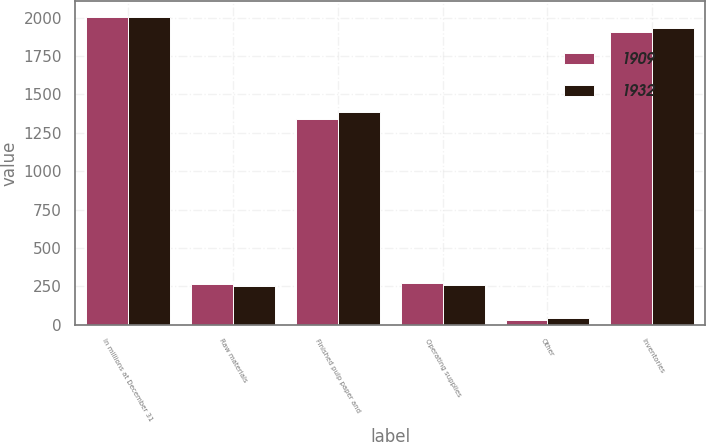Convert chart. <chart><loc_0><loc_0><loc_500><loc_500><stacked_bar_chart><ecel><fcel>In millions at December 31<fcel>Raw materials<fcel>Finished pulp paper and<fcel>Operating supplies<fcel>Other<fcel>Inventories<nl><fcel>1909<fcel>2006<fcel>265<fcel>1341<fcel>271<fcel>32<fcel>1909<nl><fcel>1932<fcel>2005<fcel>249<fcel>1383<fcel>259<fcel>41<fcel>1932<nl></chart> 